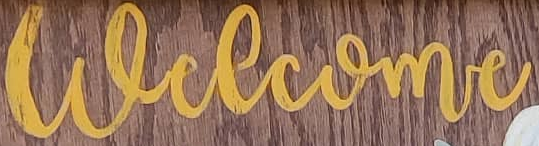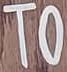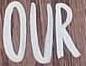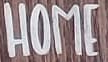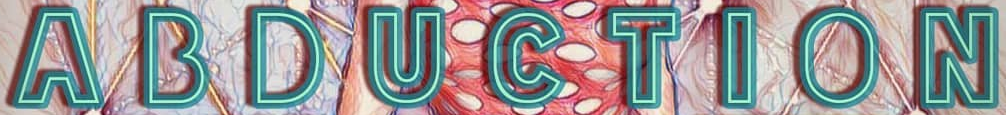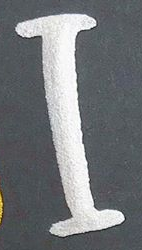What words can you see in these images in sequence, separated by a semicolon? welcome; TO; OUR; HOME; ABDUCTION; I 